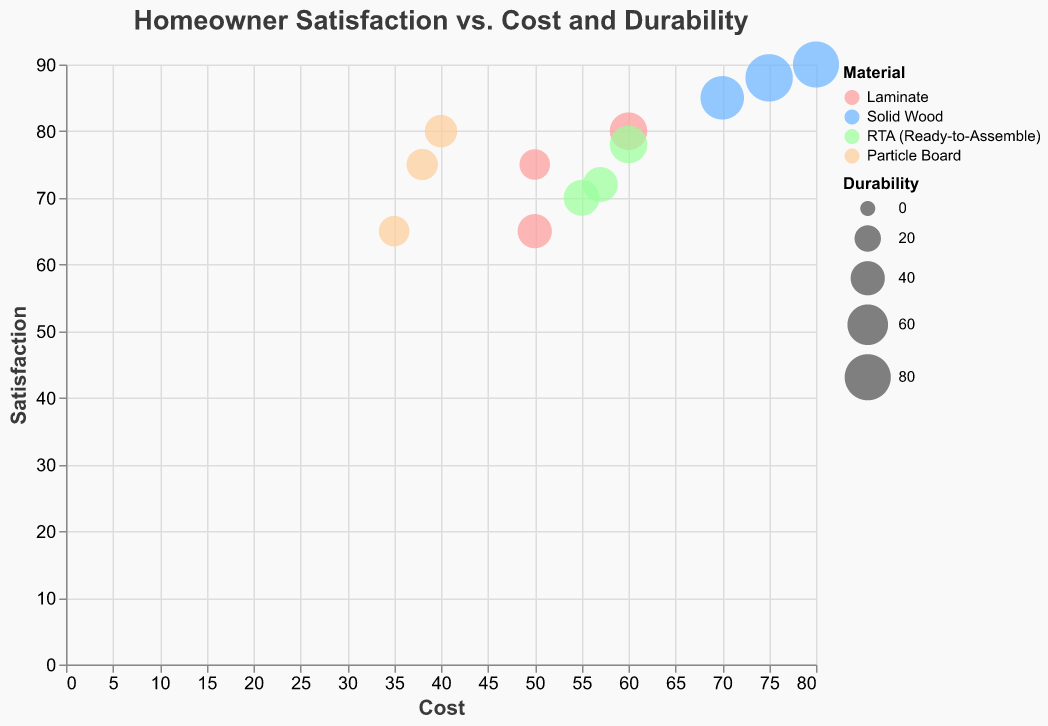What's the title of the figure? The title of the figure is located at the top. In this case, it reads, "Homeowner Satisfaction vs. Cost and Durability."
Answer: Homeowner Satisfaction vs. Cost and Durability How many different cabinet materials are represented? By examining the legend, we can see the colors representing “Laminate,” “Solid Wood,” “RTA (Ready-to-Assemble),” and “Particle Board” materials, summing up to four different materials.
Answer: Four Which material shows the highest satisfaction rating? Scan the y-axis to locate the highest value. The bubble at the top is for the material "Solid Wood" with a satisfaction rating of 90.
Answer: Solid Wood Which brand offers the most cost-effective (lowest cost) option? Look at the bubble closest to the origin on the x-axis for the "Cost." Here, Particle Board from Amazon has the lowest cost of 35.
Answer: Amazon Which material provides the best durability? Check the sizes of the bubbles to compare durability. The largest bubble represents Solid Wood from Menards, with a durability of 85.
Answer: Solid Wood What is the satisfaction difference between the highest and lowest rated materials? The highest satisfaction rating is 90 (Solid Wood, Lowes) and the lowest is 65 (Particle Board, Amazon). The difference is 90 - 65.
Answer: 25 In the budget-friendly particle board category, which brand has the highest satisfaction? Within the Particle Board material bubbles, compare the y-axis (Satisfaction). IKEA has the highest satisfaction rating of 80.
Answer: IKEA Between Laminate and RTA, which material has more options in the plot? Count the bubbles for each material. Laminate has three (IKEA, Home Depot, Lowes), and RTA has three (Cabinets To Go, Mainstays, South Shore). Hence, they have an equal number of options represented.
Answer: Equal Does a higher cost generally correlate with higher satisfaction for Solid Wood options? Identify Solid Wood bubbles and observe their positions along the x-axis (Cost) and y-axis (Satisfaction). Higher costs (around 70 to 80) generally pair with higher satisfaction (85 to 90). Therefore, it's a noticeable trend.
Answer: Yes Which material-brand combination shows an almost equal balance in cost, satisfaction, and durability (close in size and alignment)? Look for bubbles relatively aligned diagonally near the center. RTA (Ready-to-Assemble) from South Shore has nearly equal proportions: Cost 60, Satisfaction 78, and Durability 50.
Answer: RTA (Ready-to-Assemble) – South Shore 